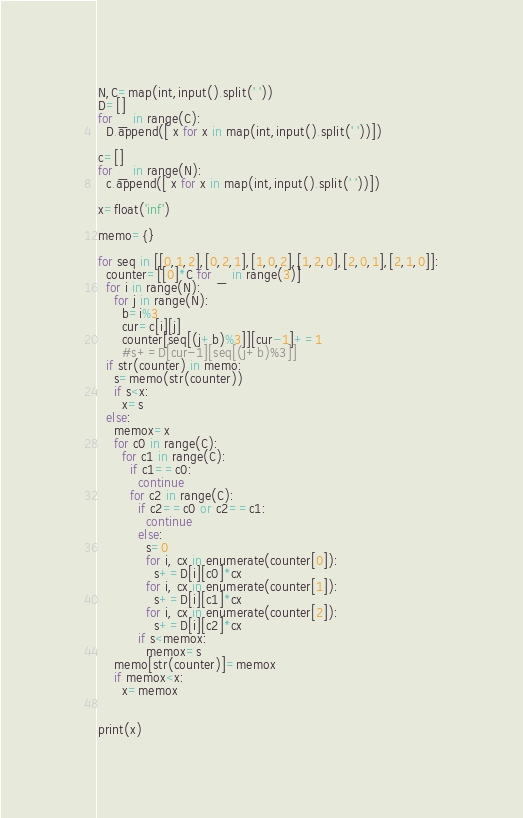Convert code to text. <code><loc_0><loc_0><loc_500><loc_500><_Python_>N,C=map(int,input().split(' '))
D=[]
for _ in range(C):
  D.append([ x for x in map(int,input().split(' '))])

c=[]
for _ in range(N):
  c.append([ x for x in map(int,input().split(' '))])

x=float('inf')

memo={}

for seq in [[0,1,2],[0,2,1],[1,0,2],[1,2,0],[2,0,1],[2,1,0]]:
  counter=[[0]*C for _ in range(3)]
  for i in range(N):
    for j in range(N):
      b=i%3
      cur=c[i][j]
      counter[seq[(j+b)%3]][cur-1]+=1
      #s+=D[cur-1][seq[(j+b)%3]]
  if str(counter) in memo:
    s=memo(str(counter))
    if s<x:
      x=s
  else:
    memox=x
    for c0 in range(C):
      for c1 in range(C):
        if c1==c0:
          continue
        for c2 in range(C):
          if c2==c0 or c2==c1:
            continue
          else:
            s=0
            for i, cx in enumerate(counter[0]):
              s+=D[i][c0]*cx
            for i, cx in enumerate(counter[1]):
              s+=D[i][c1]*cx
            for i, cx in enumerate(counter[2]):
              s+=D[i][c2]*cx
          if s<memox:
            memox=s
    memo[str(counter)]=memox
    if memox<x:
      x=memox


print(x)

</code> 